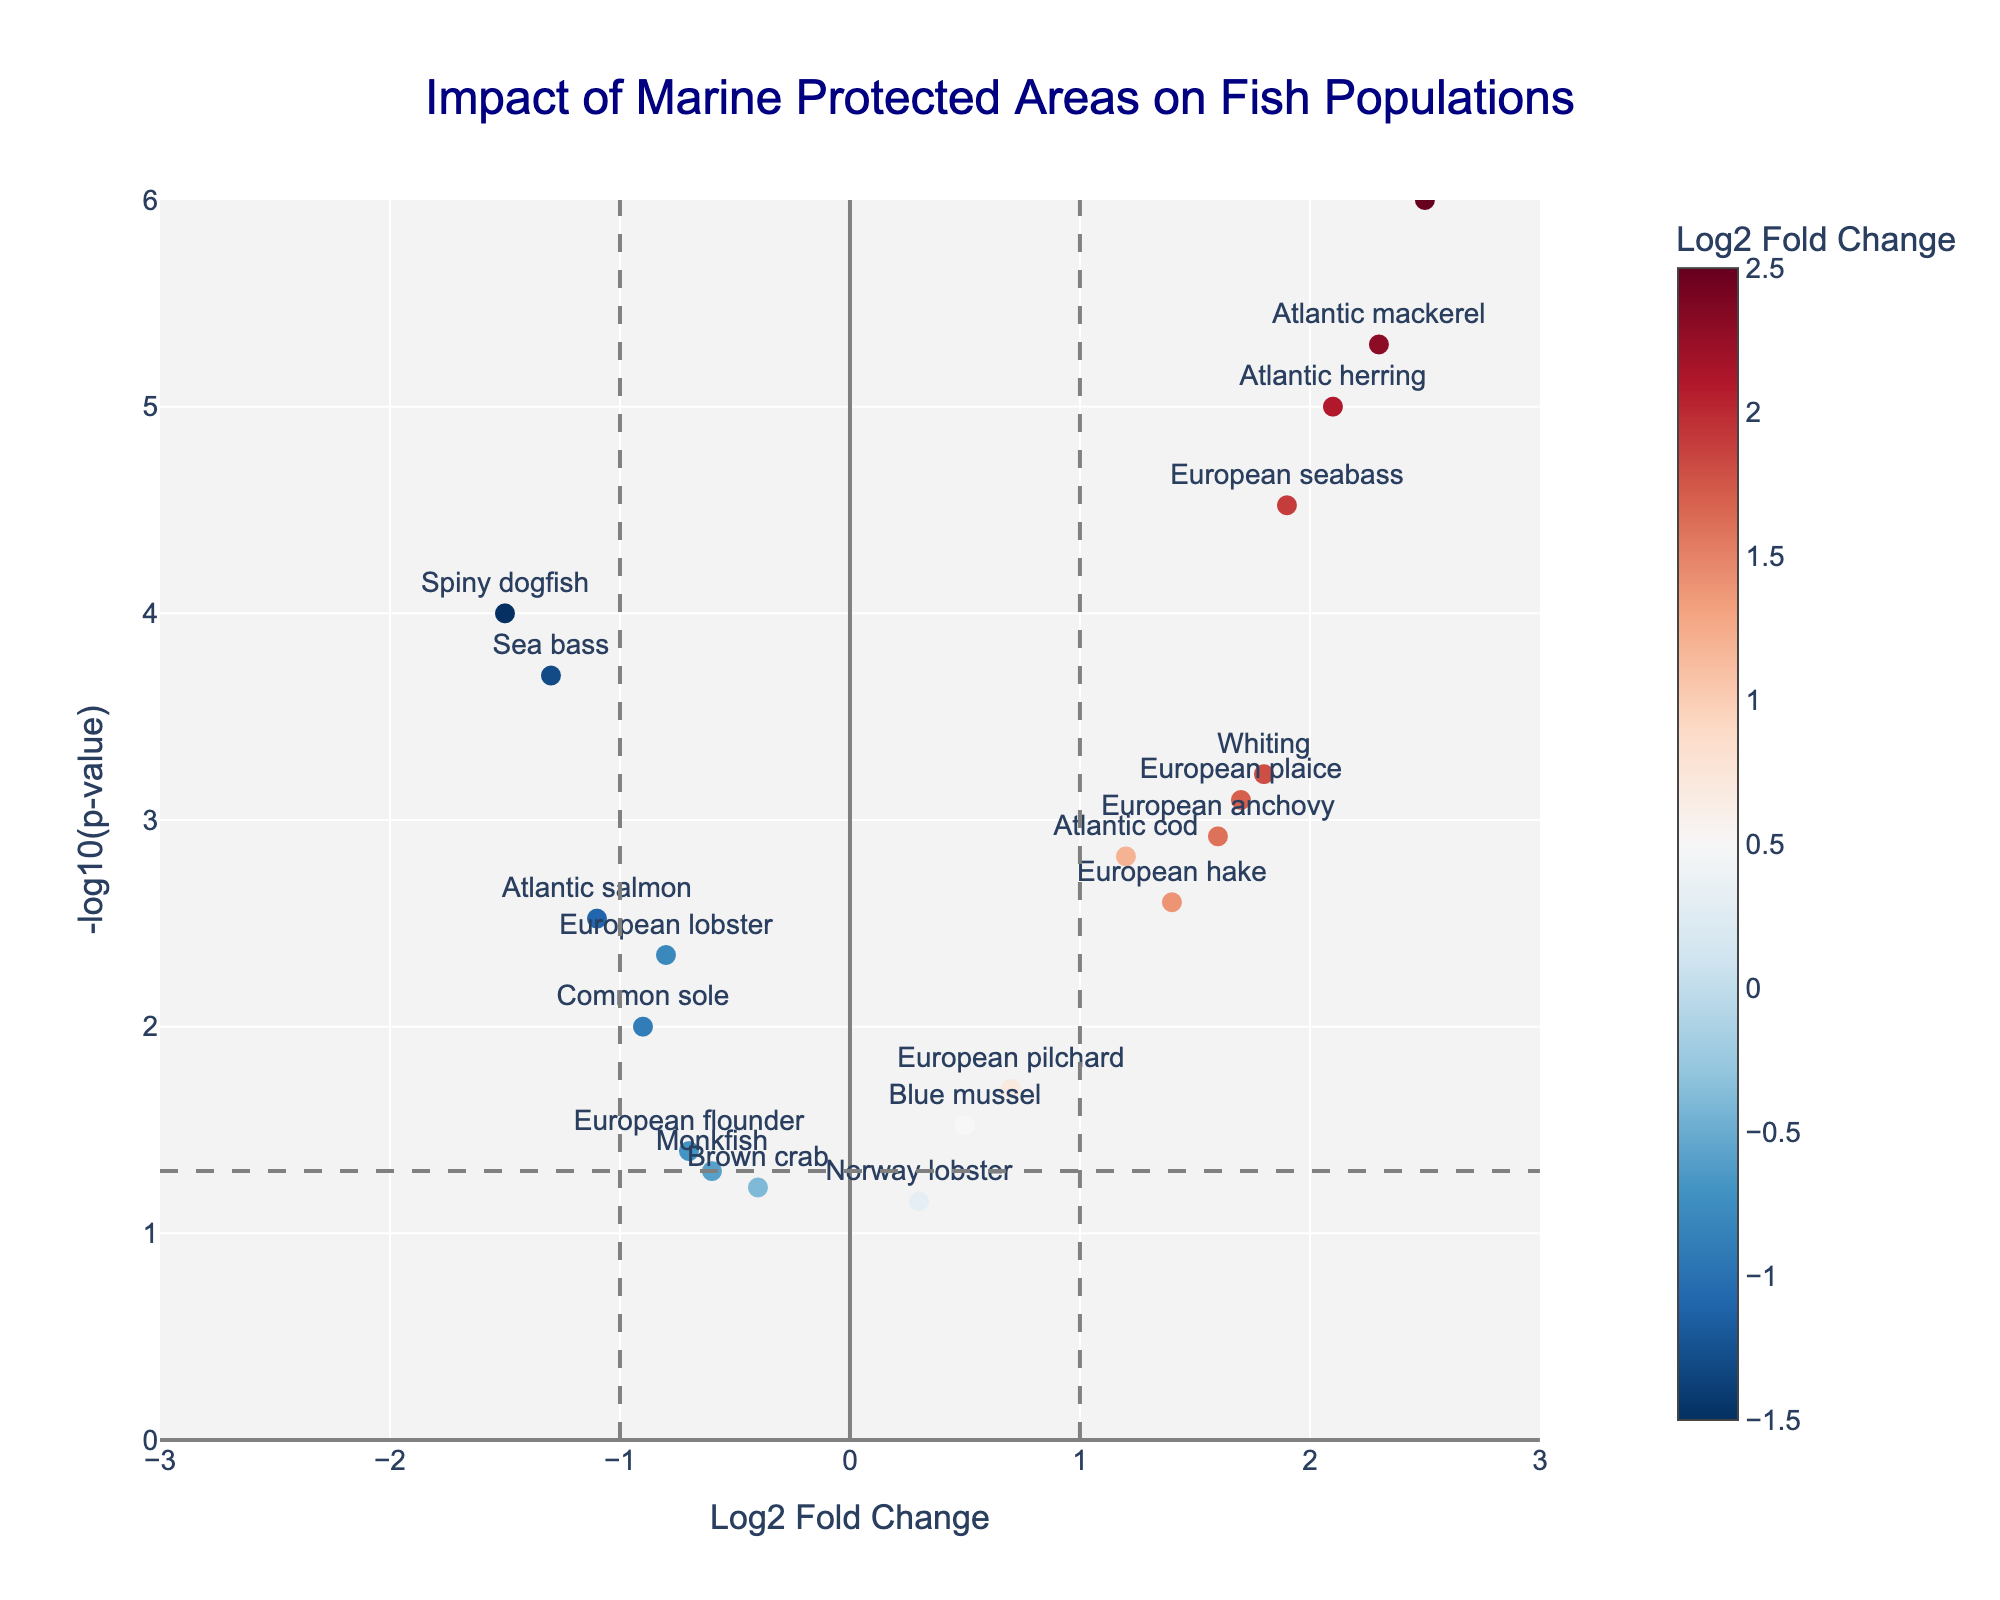What's the title of the figure? The title of a figure is usually stated clearly at the top. Here, it reads "Impact of Marine Protected Areas on Fish Populations"
Answer: Impact of Marine Protected Areas on Fish Populations What is the x-axis representing? The label on the x-axis indicates that it represents "Log2 Fold Change"
Answer: Log2 Fold Change How many data points have a Log2 Fold Change above 1? By counting the points to the right of the vertical line at x=1, we can see which species have a Log2 Fold Change above 1
Answer: 8 Which species has the highest Log2 Fold Change? Look for the right-most point on the x-axis and identify the species label. The highest Log2 Fold Change is for "Atlantic bonito"
Answer: Atlantic bonito Which species has the lowest p-value? The species with the lowest p-value will be the highest point on the y-axis, due to the inverse relationship in the -log10 scale
Answer: Atlantic mackerel Are there any species with significantly negative Log2 Fold Change and low p-values (< 0.05)? Identify the points with Log2 Fold Change less than 0 and above the horizontal line that represents p-value = 0.05
Answer: Yes, European lobster, Sea bass, Spiny dogfish, and Atlantic salmon Which species is closest to the threshold line of Log2 Fold Change = 1 but still greater than 1? Look for points that are slightly right of the vertical line at x=1 and identify the closest one
Answer: European hake How many species have a -log10(p-value) above 2? Count the number of points above the horizontal line at y=2 (-log10(0.01), which is a common significance threshold)
Answer: 13 Which species has the smallest Log2 Fold Change among those with p-values below 0.05? Among the species with Log2 Fold Change less than 0 and p-value less than 0.05, identify the one with the lowest x-value
Answer: Spiny dogfish What does the color of the markers represent in this plot? The color intensity often represents another variable, indicated by the color bar. Here, it is "Log2 Fold Change" as shown in the legend
Answer: Log2 Fold Change 